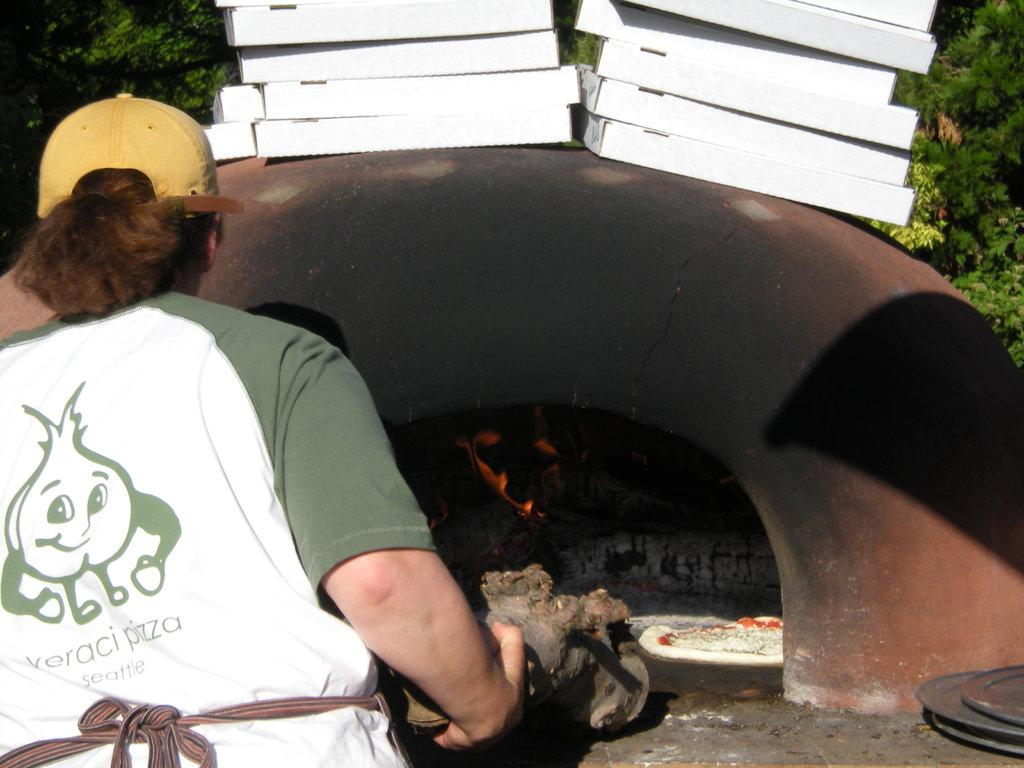<image>
Summarize the visual content of the image. A pizza oven is being used at Veraci Pizza in Seattle 